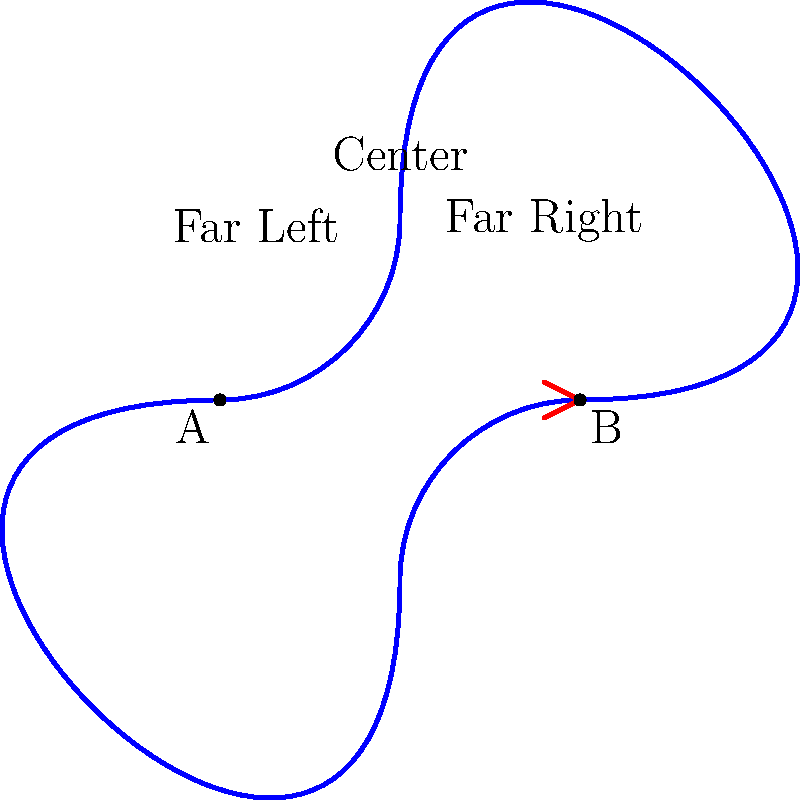Consider a Möbius strip representing the political spectrum, where point A represents the far left, the center is at the top, and point B represents the far right. If you start at point A and travel along the strip, how many complete revolutions around the strip will you make before reaching point B on the opposite side? To understand this problem, let's break it down step-by-step:

1. A Möbius strip is a topological object with only one side and one edge. It's created by taking a strip of paper, giving it a half-twist, and then joining the ends.

2. In this representation, the political spectrum is mapped onto the Möbius strip, with the far left at point A, the center at the top, and the far right at point B.

3. The key property of a Möbius strip is that if you trace a path along its surface, you will eventually return to your starting point after traversing both "sides" of the strip.

4. However, the question asks about reaching point B, which is on the "opposite" side of the strip from point A.

5. To reach point B from point A, you need to travel along the entire length of the strip once.

6. During this journey, you will make exactly one half-revolution around the strip.

7. This is because a Möbius strip has a half-twist, so traveling its entire length only takes you halfway around in terms of revolutions.

8. Therefore, you will not complete any full revolutions before reaching point B.

This illustrates how extreme political views on opposite ends of the spectrum can actually be closer to each other than to the center, reflecting the often observed phenomenon of horseshoe theory in political science.
Answer: 0 revolutions 